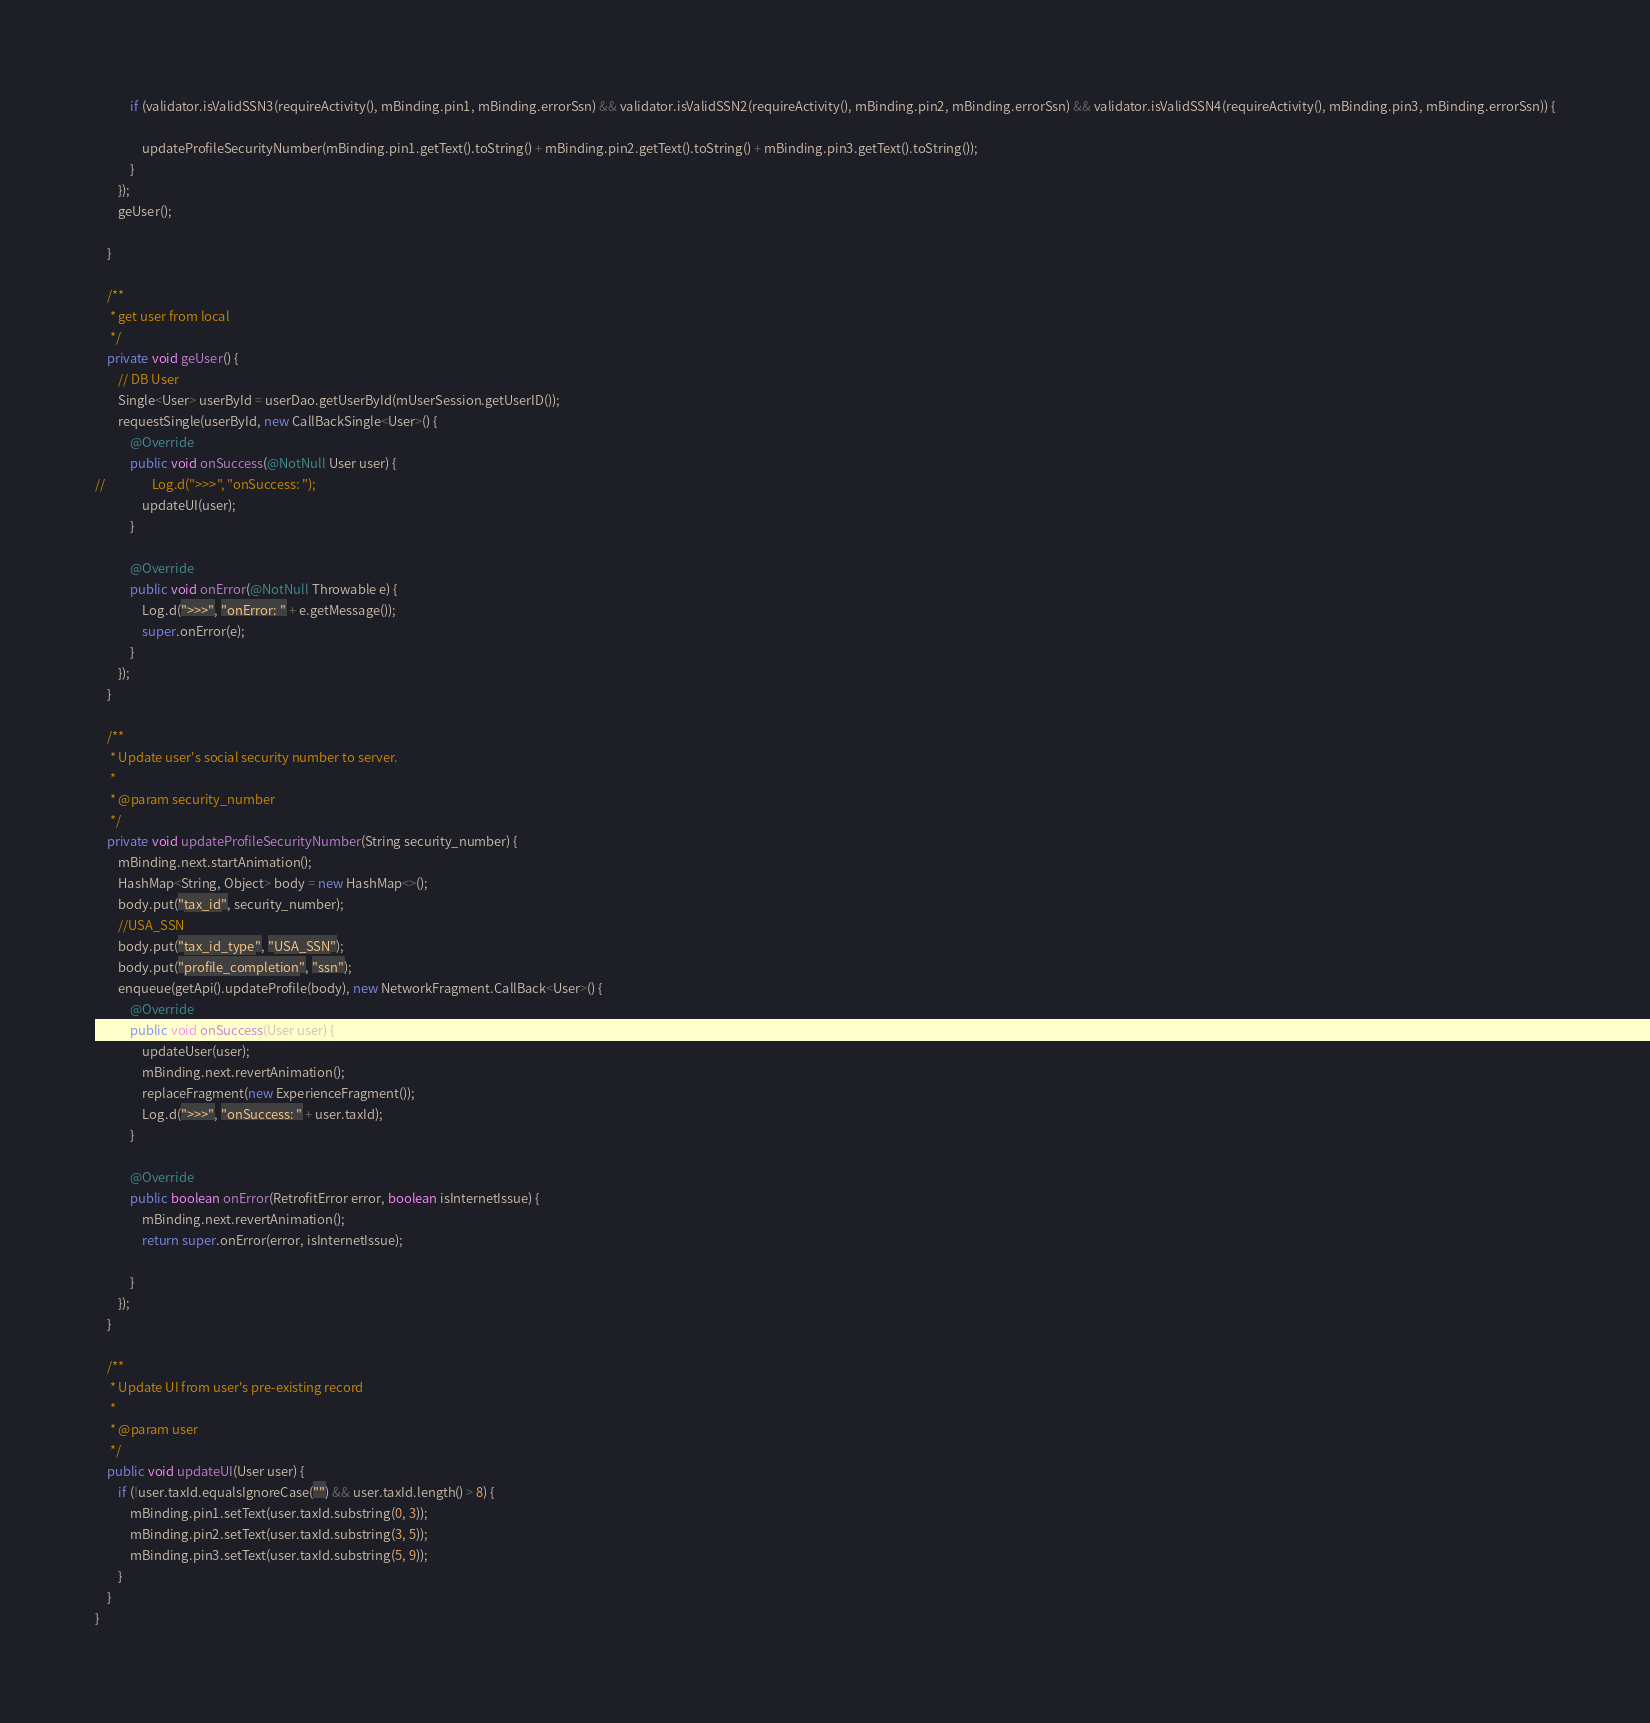Convert code to text. <code><loc_0><loc_0><loc_500><loc_500><_Java_>
            if (validator.isValidSSN3(requireActivity(), mBinding.pin1, mBinding.errorSsn) && validator.isValidSSN2(requireActivity(), mBinding.pin2, mBinding.errorSsn) && validator.isValidSSN4(requireActivity(), mBinding.pin3, mBinding.errorSsn)) {

                updateProfileSecurityNumber(mBinding.pin1.getText().toString() + mBinding.pin2.getText().toString() + mBinding.pin3.getText().toString());
            }
        });
        geUser();

    }

    /**
     * get user from local
     */
    private void geUser() {
        // DB User
        Single<User> userById = userDao.getUserById(mUserSession.getUserID());
        requestSingle(userById, new CallBackSingle<User>() {
            @Override
            public void onSuccess(@NotNull User user) {
//                Log.d(">>>", "onSuccess: ");
                updateUI(user);
            }

            @Override
            public void onError(@NotNull Throwable e) {
                Log.d(">>>", "onError: " + e.getMessage());
                super.onError(e);
            }
        });
    }

    /**
     * Update user's social security number to server.
     *
     * @param security_number
     */
    private void updateProfileSecurityNumber(String security_number) {
        mBinding.next.startAnimation();
        HashMap<String, Object> body = new HashMap<>();
        body.put("tax_id", security_number);
        //USA_SSN
        body.put("tax_id_type", "USA_SSN");
        body.put("profile_completion", "ssn");
        enqueue(getApi().updateProfile(body), new NetworkFragment.CallBack<User>() {
            @Override
            public void onSuccess(User user) {
                updateUser(user);
                mBinding.next.revertAnimation();
                replaceFragment(new ExperienceFragment());
                Log.d(">>>", "onSuccess: " + user.taxId);
            }

            @Override
            public boolean onError(RetrofitError error, boolean isInternetIssue) {
                mBinding.next.revertAnimation();
                return super.onError(error, isInternetIssue);

            }
        });
    }

    /**
     * Update UI from user's pre-existing record
     *
     * @param user
     */
    public void updateUI(User user) {
        if (!user.taxId.equalsIgnoreCase("") && user.taxId.length() > 8) {
            mBinding.pin1.setText(user.taxId.substring(0, 3));
            mBinding.pin2.setText(user.taxId.substring(3, 5));
            mBinding.pin3.setText(user.taxId.substring(5, 9));
        }
    }
}
</code> 